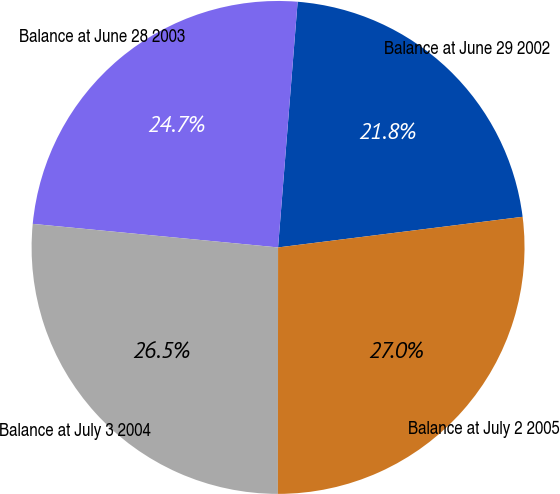Convert chart. <chart><loc_0><loc_0><loc_500><loc_500><pie_chart><fcel>Balance at June 29 2002<fcel>Balance at June 28 2003<fcel>Balance at July 3 2004<fcel>Balance at July 2 2005<nl><fcel>21.75%<fcel>24.74%<fcel>26.51%<fcel>26.99%<nl></chart> 